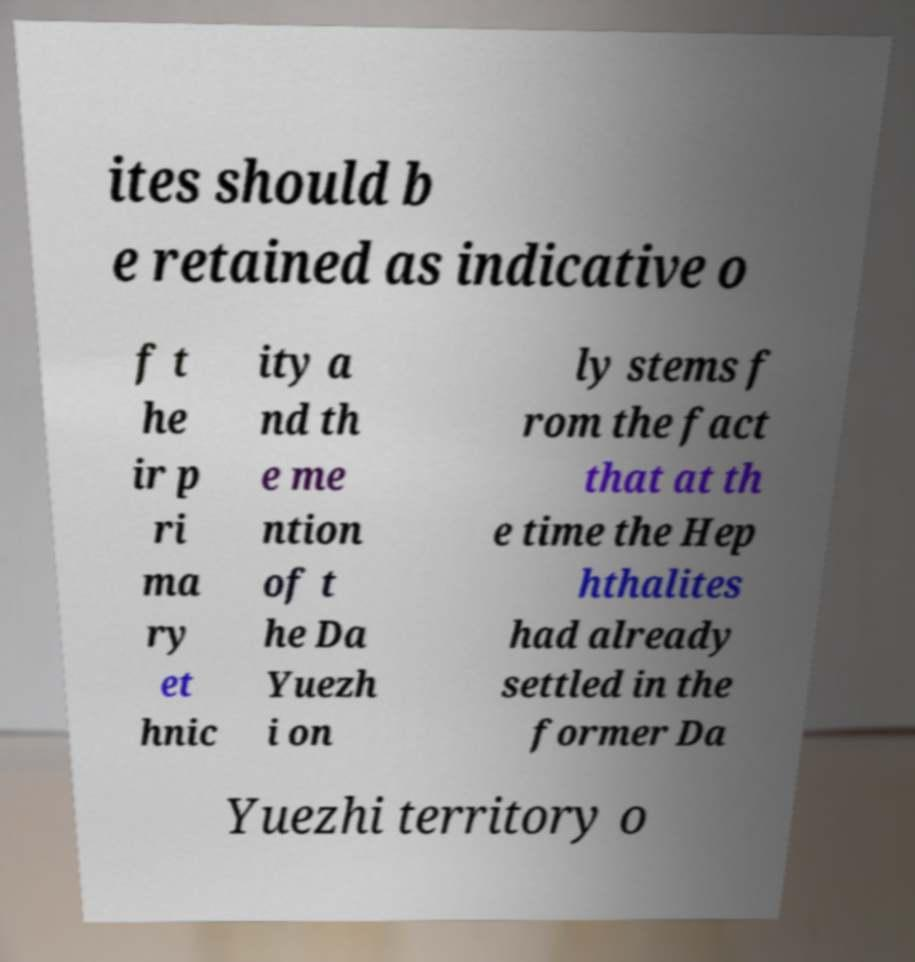There's text embedded in this image that I need extracted. Can you transcribe it verbatim? ites should b e retained as indicative o f t he ir p ri ma ry et hnic ity a nd th e me ntion of t he Da Yuezh i on ly stems f rom the fact that at th e time the Hep hthalites had already settled in the former Da Yuezhi territory o 